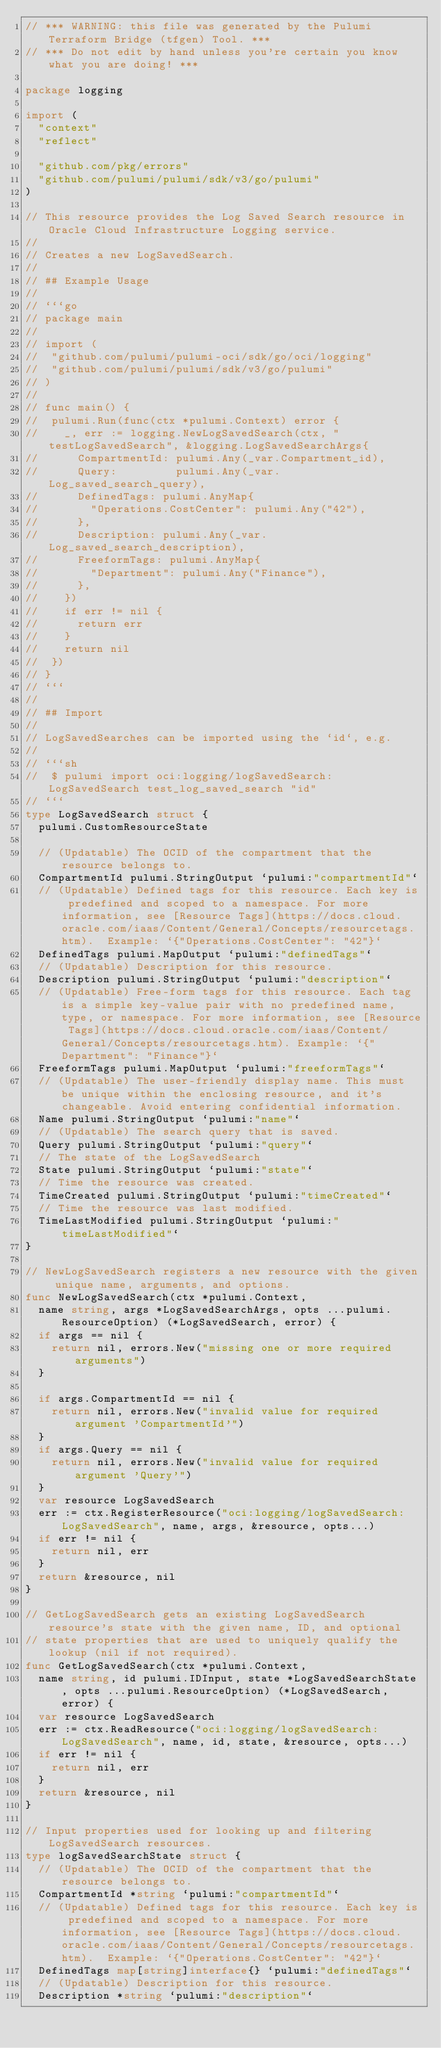<code> <loc_0><loc_0><loc_500><loc_500><_Go_>// *** WARNING: this file was generated by the Pulumi Terraform Bridge (tfgen) Tool. ***
// *** Do not edit by hand unless you're certain you know what you are doing! ***

package logging

import (
	"context"
	"reflect"

	"github.com/pkg/errors"
	"github.com/pulumi/pulumi/sdk/v3/go/pulumi"
)

// This resource provides the Log Saved Search resource in Oracle Cloud Infrastructure Logging service.
//
// Creates a new LogSavedSearch.
//
// ## Example Usage
//
// ```go
// package main
//
// import (
// 	"github.com/pulumi/pulumi-oci/sdk/go/oci/logging"
// 	"github.com/pulumi/pulumi/sdk/v3/go/pulumi"
// )
//
// func main() {
// 	pulumi.Run(func(ctx *pulumi.Context) error {
// 		_, err := logging.NewLogSavedSearch(ctx, "testLogSavedSearch", &logging.LogSavedSearchArgs{
// 			CompartmentId: pulumi.Any(_var.Compartment_id),
// 			Query:         pulumi.Any(_var.Log_saved_search_query),
// 			DefinedTags: pulumi.AnyMap{
// 				"Operations.CostCenter": pulumi.Any("42"),
// 			},
// 			Description: pulumi.Any(_var.Log_saved_search_description),
// 			FreeformTags: pulumi.AnyMap{
// 				"Department": pulumi.Any("Finance"),
// 			},
// 		})
// 		if err != nil {
// 			return err
// 		}
// 		return nil
// 	})
// }
// ```
//
// ## Import
//
// LogSavedSearches can be imported using the `id`, e.g.
//
// ```sh
//  $ pulumi import oci:logging/logSavedSearch:LogSavedSearch test_log_saved_search "id"
// ```
type LogSavedSearch struct {
	pulumi.CustomResourceState

	// (Updatable) The OCID of the compartment that the resource belongs to.
	CompartmentId pulumi.StringOutput `pulumi:"compartmentId"`
	// (Updatable) Defined tags for this resource. Each key is predefined and scoped to a namespace. For more information, see [Resource Tags](https://docs.cloud.oracle.com/iaas/Content/General/Concepts/resourcetags.htm).  Example: `{"Operations.CostCenter": "42"}`
	DefinedTags pulumi.MapOutput `pulumi:"definedTags"`
	// (Updatable) Description for this resource.
	Description pulumi.StringOutput `pulumi:"description"`
	// (Updatable) Free-form tags for this resource. Each tag is a simple key-value pair with no predefined name, type, or namespace. For more information, see [Resource Tags](https://docs.cloud.oracle.com/iaas/Content/General/Concepts/resourcetags.htm). Example: `{"Department": "Finance"}`
	FreeformTags pulumi.MapOutput `pulumi:"freeformTags"`
	// (Updatable) The user-friendly display name. This must be unique within the enclosing resource, and it's changeable. Avoid entering confidential information.
	Name pulumi.StringOutput `pulumi:"name"`
	// (Updatable) The search query that is saved.
	Query pulumi.StringOutput `pulumi:"query"`
	// The state of the LogSavedSearch
	State pulumi.StringOutput `pulumi:"state"`
	// Time the resource was created.
	TimeCreated pulumi.StringOutput `pulumi:"timeCreated"`
	// Time the resource was last modified.
	TimeLastModified pulumi.StringOutput `pulumi:"timeLastModified"`
}

// NewLogSavedSearch registers a new resource with the given unique name, arguments, and options.
func NewLogSavedSearch(ctx *pulumi.Context,
	name string, args *LogSavedSearchArgs, opts ...pulumi.ResourceOption) (*LogSavedSearch, error) {
	if args == nil {
		return nil, errors.New("missing one or more required arguments")
	}

	if args.CompartmentId == nil {
		return nil, errors.New("invalid value for required argument 'CompartmentId'")
	}
	if args.Query == nil {
		return nil, errors.New("invalid value for required argument 'Query'")
	}
	var resource LogSavedSearch
	err := ctx.RegisterResource("oci:logging/logSavedSearch:LogSavedSearch", name, args, &resource, opts...)
	if err != nil {
		return nil, err
	}
	return &resource, nil
}

// GetLogSavedSearch gets an existing LogSavedSearch resource's state with the given name, ID, and optional
// state properties that are used to uniquely qualify the lookup (nil if not required).
func GetLogSavedSearch(ctx *pulumi.Context,
	name string, id pulumi.IDInput, state *LogSavedSearchState, opts ...pulumi.ResourceOption) (*LogSavedSearch, error) {
	var resource LogSavedSearch
	err := ctx.ReadResource("oci:logging/logSavedSearch:LogSavedSearch", name, id, state, &resource, opts...)
	if err != nil {
		return nil, err
	}
	return &resource, nil
}

// Input properties used for looking up and filtering LogSavedSearch resources.
type logSavedSearchState struct {
	// (Updatable) The OCID of the compartment that the resource belongs to.
	CompartmentId *string `pulumi:"compartmentId"`
	// (Updatable) Defined tags for this resource. Each key is predefined and scoped to a namespace. For more information, see [Resource Tags](https://docs.cloud.oracle.com/iaas/Content/General/Concepts/resourcetags.htm).  Example: `{"Operations.CostCenter": "42"}`
	DefinedTags map[string]interface{} `pulumi:"definedTags"`
	// (Updatable) Description for this resource.
	Description *string `pulumi:"description"`</code> 